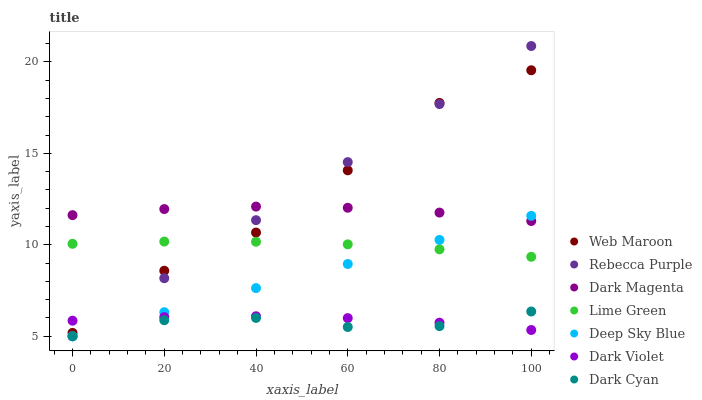Does Dark Cyan have the minimum area under the curve?
Answer yes or no. Yes. Does Rebecca Purple have the maximum area under the curve?
Answer yes or no. Yes. Does Web Maroon have the minimum area under the curve?
Answer yes or no. No. Does Web Maroon have the maximum area under the curve?
Answer yes or no. No. Is Deep Sky Blue the smoothest?
Answer yes or no. Yes. Is Web Maroon the roughest?
Answer yes or no. Yes. Is Dark Violet the smoothest?
Answer yes or no. No. Is Dark Violet the roughest?
Answer yes or no. No. Does Rebecca Purple have the lowest value?
Answer yes or no. Yes. Does Web Maroon have the lowest value?
Answer yes or no. No. Does Rebecca Purple have the highest value?
Answer yes or no. Yes. Does Web Maroon have the highest value?
Answer yes or no. No. Is Lime Green less than Dark Magenta?
Answer yes or no. Yes. Is Dark Magenta greater than Dark Violet?
Answer yes or no. Yes. Does Dark Magenta intersect Deep Sky Blue?
Answer yes or no. Yes. Is Dark Magenta less than Deep Sky Blue?
Answer yes or no. No. Is Dark Magenta greater than Deep Sky Blue?
Answer yes or no. No. Does Lime Green intersect Dark Magenta?
Answer yes or no. No. 